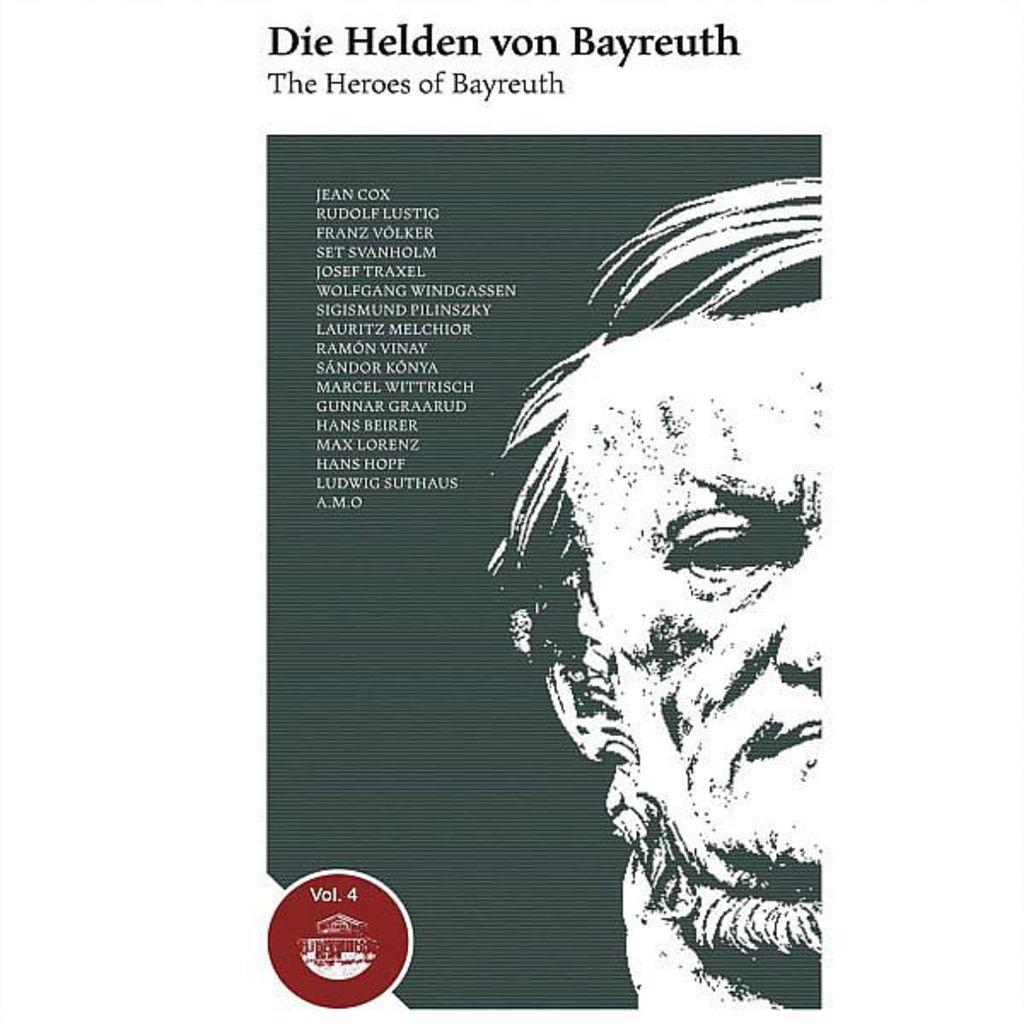What is the main subject of the image? There is a person in the image. Can you describe any additional elements in the image? There is text or writing visible in the image. What is the purpose of the sky in the image? The sky is not mentioned in the provided facts, so we cannot determine its purpose in the image. 